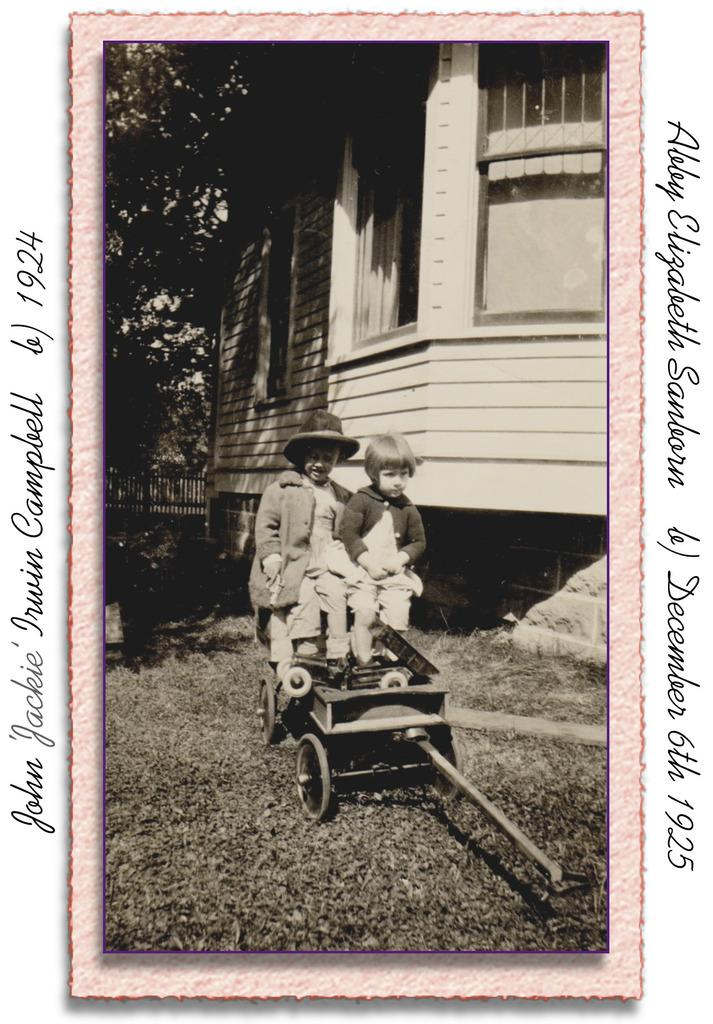What is depicted on the poster in the image? The poster contains two persons sitting on a cart. What type of structure can be seen in the image? There is a building in the image. What natural elements are present in the image? There are trees in the image. What man-made structure is visible in the image? There is a fence in the image. Can you see any waves in the image? There are no waves present in the image. Is there a boat visible in the image? There is no boat present in the image. 